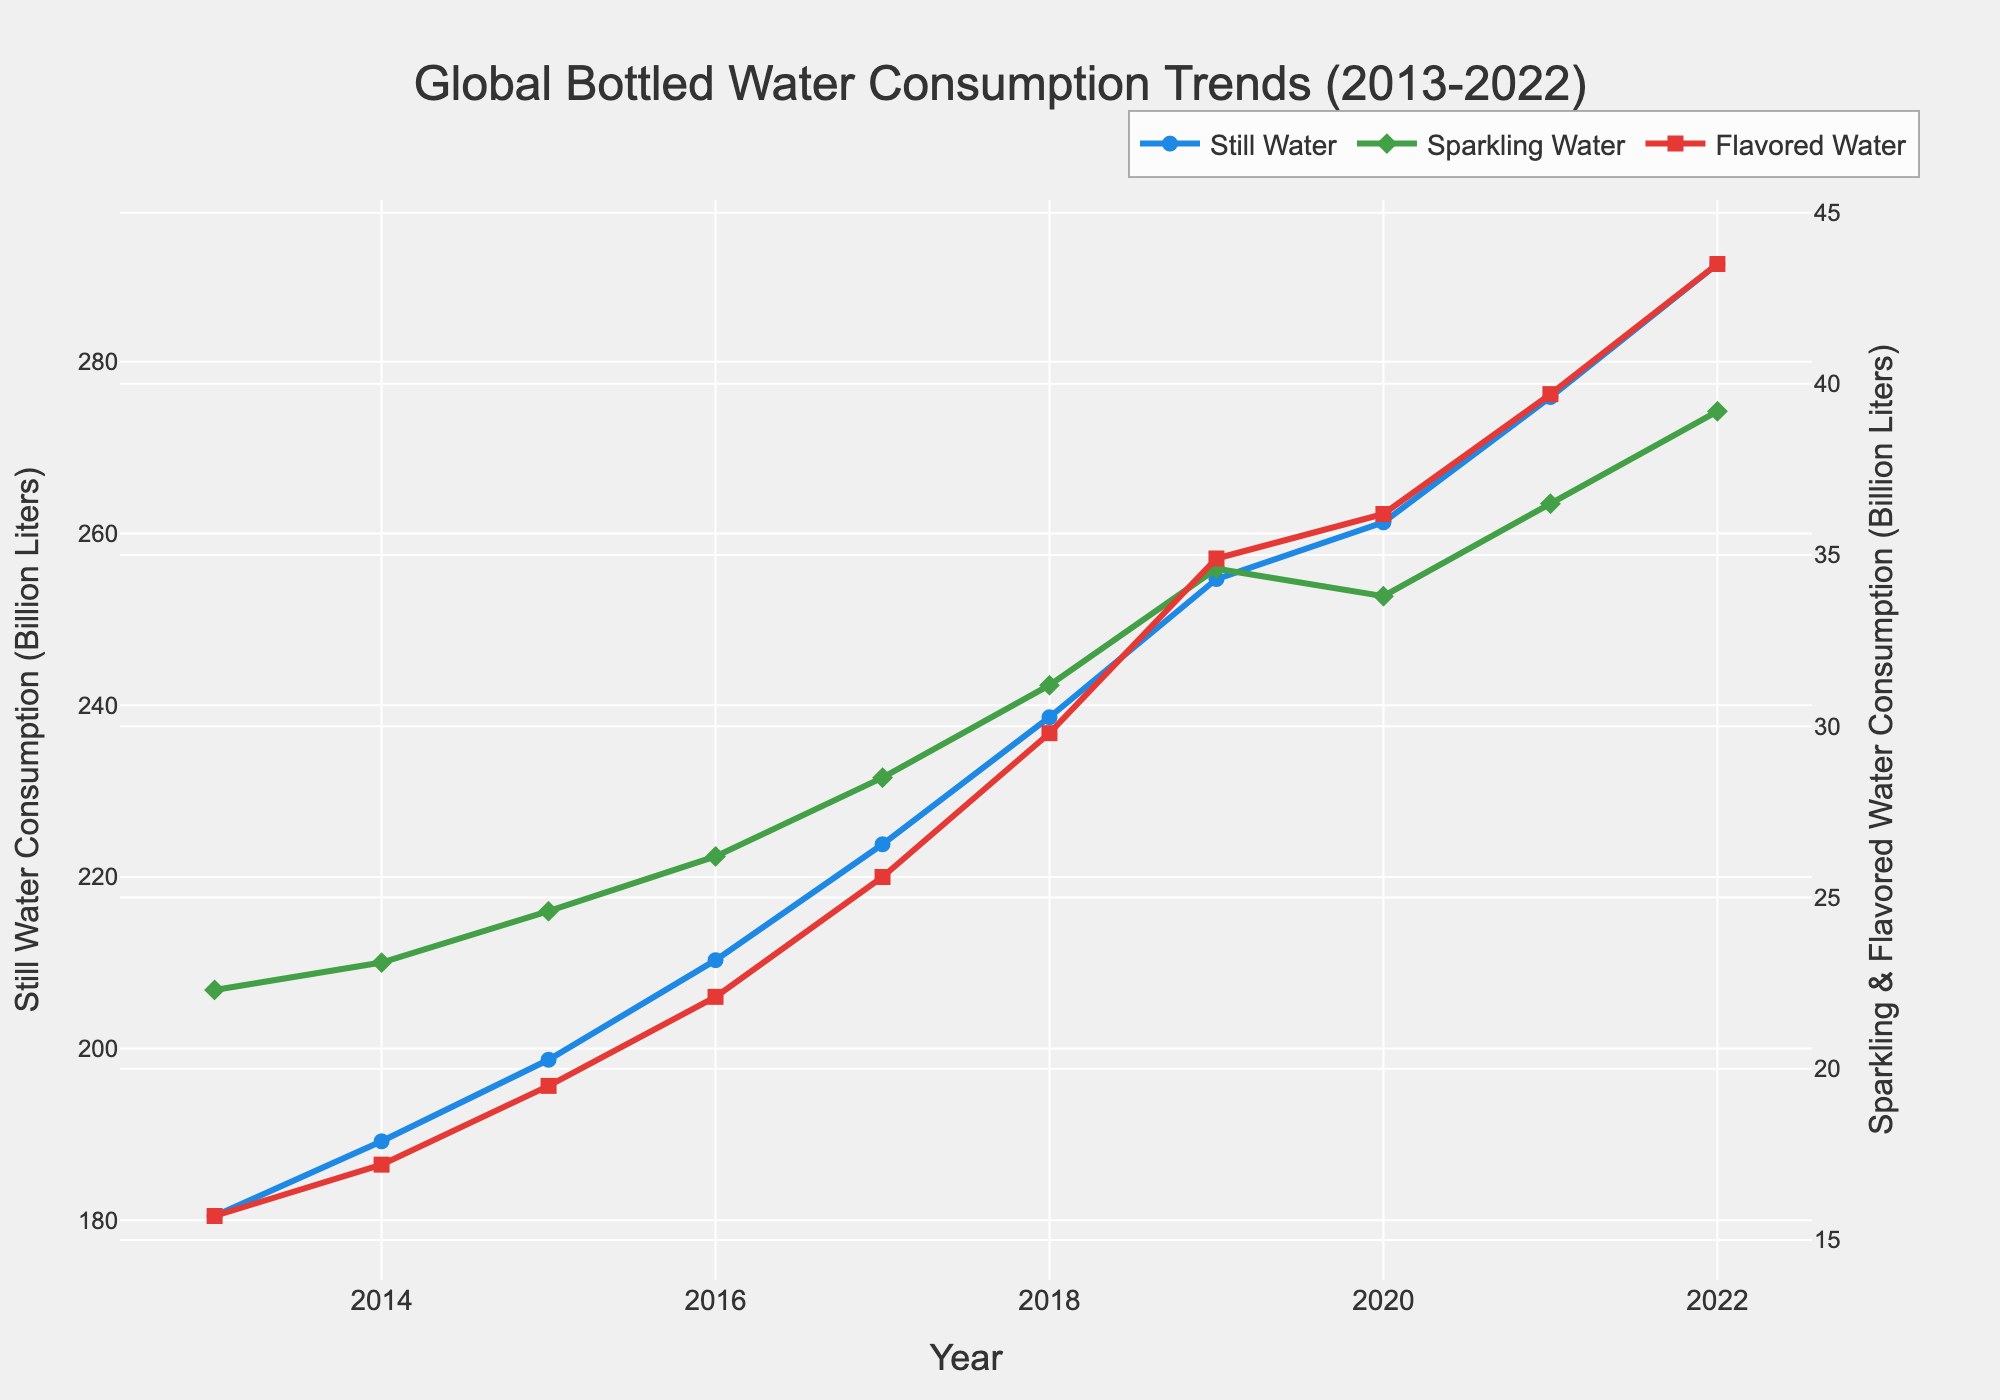What's the trend for still water consumption from 2013 to 2022? To observe the trend, examine the blue line in the figure representing still water consumption over the years 2013 to 2022. The line steadily increases from 180.5 billion liters in 2013 to 291.4 billion liters in 2022.
Answer: Increasing Which year saw the highest consumption of sparkling water? Look at the green line on the graph representing sparkling water. The highest point on the green line is in 2022, indicating the peak consumption of 39.2 billion liters.
Answer: 2022 In which year did flavored water consumption surpass sparkling water consumption? Check the years where the red line (flavored water) is higher than the green line (sparkling water). In 2020, flavored water at 36.2 billion liters surpassed sparkling water at 33.8 billion liters.
Answer: 2020 What is the difference in consumption between still and flavored water in 2022? For 2022, still water consumption is 291.4 billion liters and flavored water is 43.5 billion liters. The difference = 291.4 - 43.5 = 247.9 billion liters.
Answer: 247.9 billion liters How much did still water consumption increase from 2013 to 2022? Subtract the still water consumption in 2013 (180.5 billion liters) from that in 2022 (291.4 billion liters). Increase = 291.4 - 180.5 = 110.9 billion liters.
Answer: 110.9 billion liters What was the combined consumption of flavored and sparkling water in 2019? Add the 2019 consumption for flavored water (34.9 billion liters) and sparkling water (34.6 billion liters). Combined consumption = 34.9 + 34.6 = 69.5 billion liters.
Answer: 69.5 billion liters Which type of water experienced the most growth between 2017 and 2022? Calculate the growth for each type of water by subtracting the 2017 value from the 2022 value: Still Water (291.4 - 223.8 = 67.6 billion liters), Sparkling Water (39.2 - 28.5 = 10.7 billion liters), Flavored Water (43.5 - 25.6 = 17.9 billion liters). The highest growth is for still water.
Answer: Still Water What is the average consumption of sparkling water over the decade? Sum the sparkling water consumption values for each year (22.3 + 23.1 + 24.6 + 26.2 + 28.5 + 31.2 + 34.6 + 33.8 + 36.5 + 39.2) = 299 and divide by the number of years (10). Average = 299 / 10 = 29.9 billion liters.
Answer: 29.9 billion liters In which year did still water consumption increase the most compared to the previous year? Analyze the yearly increments for still water: 2014 (189.2-180.5=8.7), 2015 (198.7-189.2=9.5), 2016 (210.3-198.7=11.6), 2017 (223.8-210.3=13.5), 2018 (238.6-223.8=14.8), 2019 (254.7-238.6=16.1), 2020 (261.3-254.7=6.6), 2021 (275.9-261.3=14.6), 2022 (291.4-275.9=15.5). The biggest increase is 16.1 billion liters in 2019.
Answer: 2019 By how much did flavored water consumption exceed sparkling water consumption in 2021? For 2021, flavored water consumption is 39.7 billion liters and sparkling water is 36.5 billion liters. The excess = 39.7 - 36.5 = 3.2 billion liters.
Answer: 3.2 billion liters 